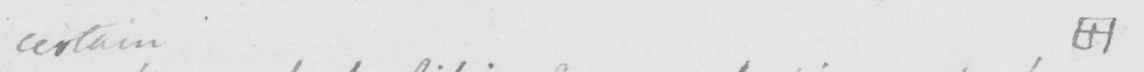Can you tell me what this handwritten text says? certain  [  +  ] 